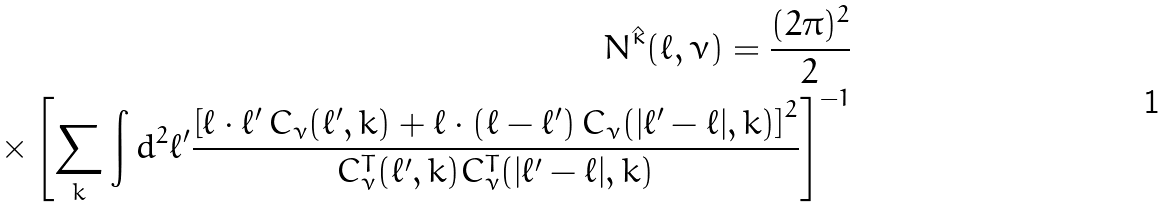<formula> <loc_0><loc_0><loc_500><loc_500>N ^ { \hat { \kappa } } ( \ell , \nu ) = \frac { ( 2 \pi ) ^ { 2 } } { 2 } \\ \times \left [ \sum _ { k } \int d ^ { 2 } \ell ^ { \prime } \frac { \left [ \ell \cdot \ell ^ { \prime } \, C _ { \nu } ( \ell ^ { \prime } , k ) + \ell \cdot ( \ell - \ell ^ { \prime } ) \, C _ { \nu } ( | \ell ^ { \prime } - \ell | , k ) \right ] ^ { 2 } } { C ^ { T } _ { \nu } ( \ell ^ { \prime } , k ) C ^ { T } _ { \nu } ( | \ell ^ { \prime } - \ell | , k ) } \right ] ^ { - 1 }</formula> 